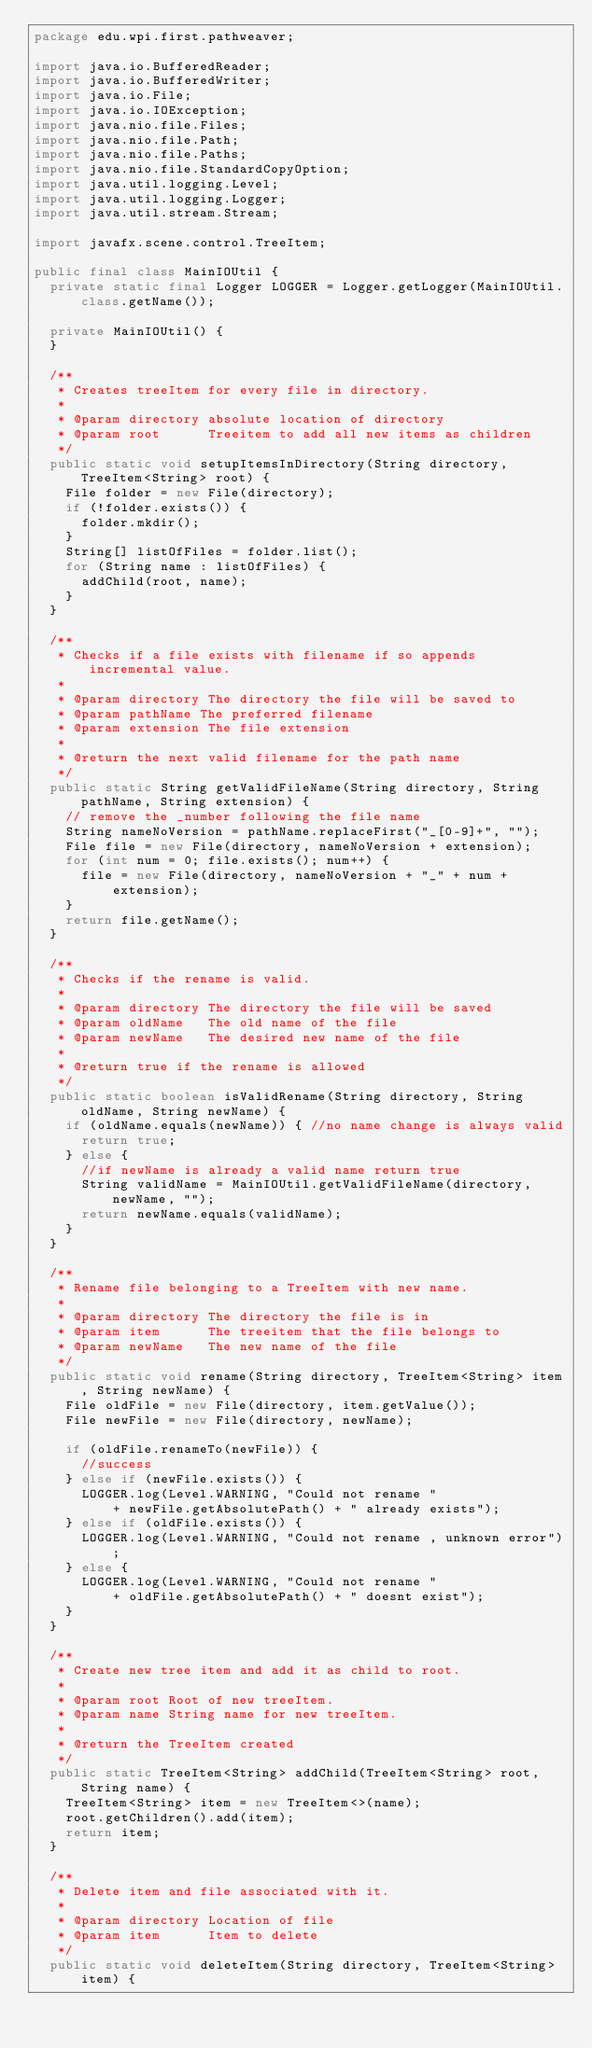Convert code to text. <code><loc_0><loc_0><loc_500><loc_500><_Java_>package edu.wpi.first.pathweaver;

import java.io.BufferedReader;
import java.io.BufferedWriter;
import java.io.File;
import java.io.IOException;
import java.nio.file.Files;
import java.nio.file.Path;
import java.nio.file.Paths;
import java.nio.file.StandardCopyOption;
import java.util.logging.Level;
import java.util.logging.Logger;
import java.util.stream.Stream;

import javafx.scene.control.TreeItem;

public final class MainIOUtil {
  private static final Logger LOGGER = Logger.getLogger(MainIOUtil.class.getName());

  private MainIOUtil() {
  }

  /**
   * Creates treeItem for every file in directory.
   *
   * @param directory absolute location of directory
   * @param root      Treeitem to add all new items as children
   */
  public static void setupItemsInDirectory(String directory, TreeItem<String> root) {
    File folder = new File(directory);
    if (!folder.exists()) {
      folder.mkdir();
    }
    String[] listOfFiles = folder.list();
    for (String name : listOfFiles) {
      addChild(root, name);
    }
  }

  /**
   * Checks if a file exists with filename if so appends incremental value.
   *
   * @param directory The directory the file will be saved to
   * @param pathName The preferred filename
   * @param extension The file extension
   *
   * @return the next valid filename for the path name
   */
  public static String getValidFileName(String directory, String pathName, String extension) {
    // remove the _number following the file name
    String nameNoVersion = pathName.replaceFirst("_[0-9]+", "");
    File file = new File(directory, nameNoVersion + extension);
    for (int num = 0; file.exists(); num++) {
      file = new File(directory, nameNoVersion + "_" + num + extension);
    }
    return file.getName();
  }

  /**
   * Checks if the rename is valid.
   *
   * @param directory The directory the file will be saved
   * @param oldName   The old name of the file
   * @param newName   The desired new name of the file
   *
   * @return true if the rename is allowed
   */
  public static boolean isValidRename(String directory, String oldName, String newName) {
    if (oldName.equals(newName)) { //no name change is always valid
      return true;
    } else {
      //if newName is already a valid name return true
      String validName = MainIOUtil.getValidFileName(directory, newName, "");
      return newName.equals(validName);
    }
  }

  /**
   * Rename file belonging to a TreeItem with new name.
   *
   * @param directory The directory the file is in
   * @param item      The treeitem that the file belongs to
   * @param newName   The new name of the file
   */
  public static void rename(String directory, TreeItem<String> item, String newName) {
    File oldFile = new File(directory, item.getValue());
    File newFile = new File(directory, newName);

    if (oldFile.renameTo(newFile)) {
      //success
    } else if (newFile.exists()) {
      LOGGER.log(Level.WARNING, "Could not rename "
          + newFile.getAbsolutePath() + " already exists");
    } else if (oldFile.exists()) {
      LOGGER.log(Level.WARNING, "Could not rename , unknown error");
    } else {
      LOGGER.log(Level.WARNING, "Could not rename "
          + oldFile.getAbsolutePath() + " doesnt exist");
    }
  }

  /**
   * Create new tree item and add it as child to root.
   *
   * @param root Root of new treeItem.
   * @param name String name for new treeItem.
   *
   * @return the TreeItem created
   */
  public static TreeItem<String> addChild(TreeItem<String> root, String name) {
    TreeItem<String> item = new TreeItem<>(name);
    root.getChildren().add(item);
    return item;
  }

  /**
   * Delete item and file associated with it.
   *
   * @param directory Location of file
   * @param item      Item to delete
   */
  public static void deleteItem(String directory, TreeItem<String> item) {
</code> 